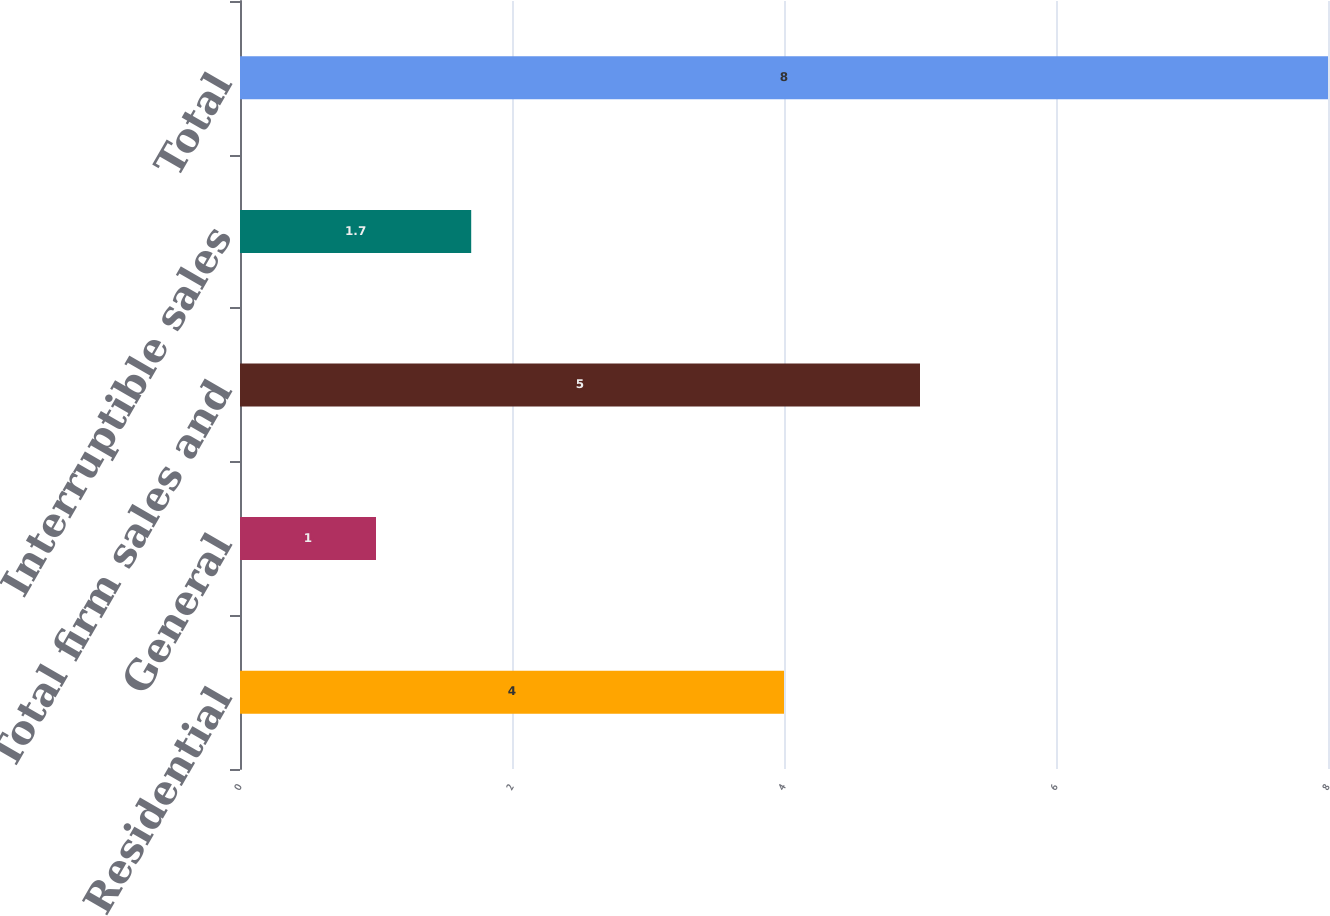Convert chart. <chart><loc_0><loc_0><loc_500><loc_500><bar_chart><fcel>Residential<fcel>General<fcel>Total firm sales and<fcel>Interruptible sales<fcel>Total<nl><fcel>4<fcel>1<fcel>5<fcel>1.7<fcel>8<nl></chart> 